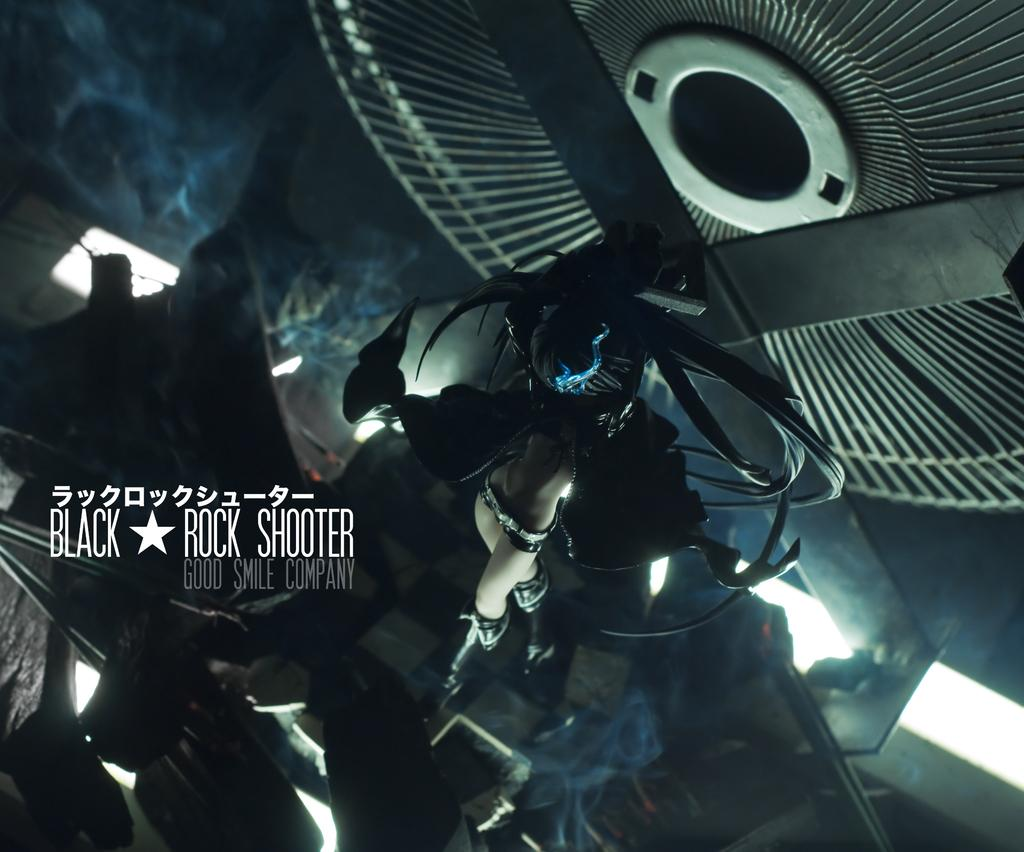<image>
Render a clear and concise summary of the photo. A dark photo of a game and text that reads Black * Rock shooter 